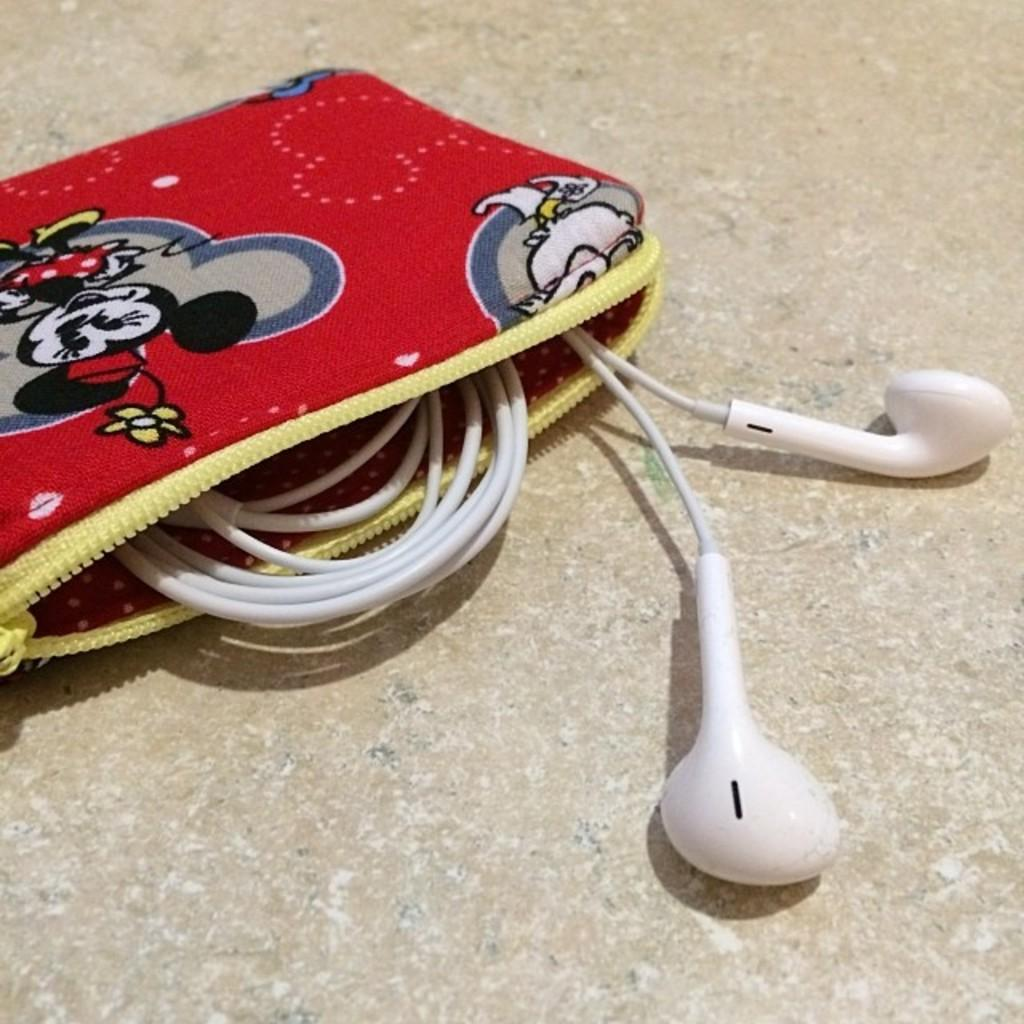What is the main object in the image? There is an earphone in the image. Where is the earphone located? The earphone is in a pouch. How many pies are being held by the boys in the image? There are no boys or pies present in the image; it only features an earphone in a pouch. 